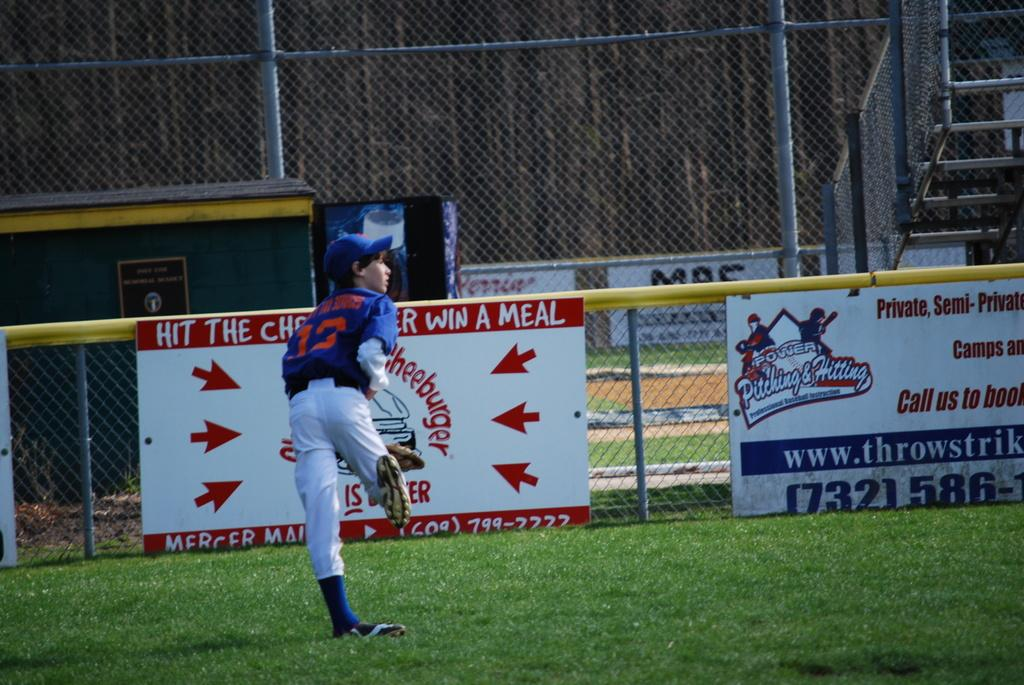<image>
Present a compact description of the photo's key features. a young boy in the baseball outfield running twaords a sign that says hit the cheeseburger win a meal 